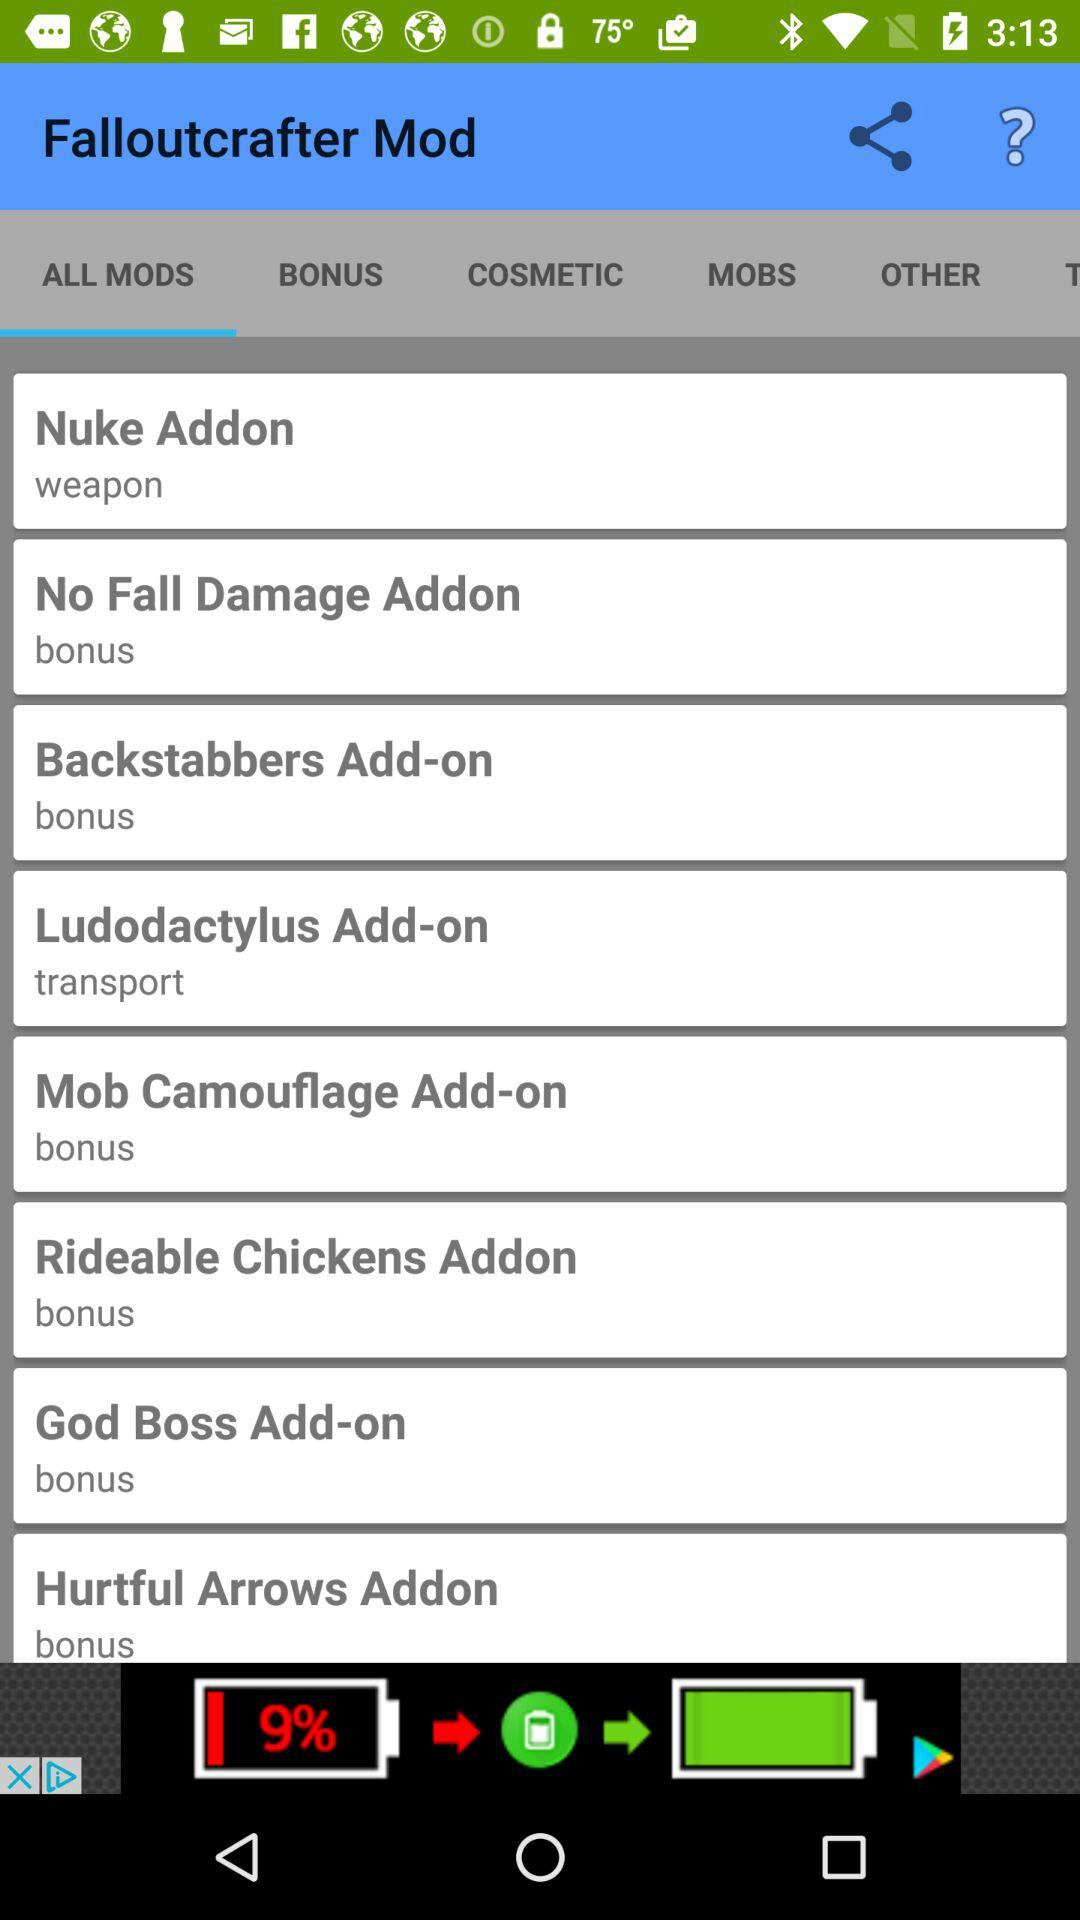What is the application name? The application name is "Falloutcrafter Mod". 